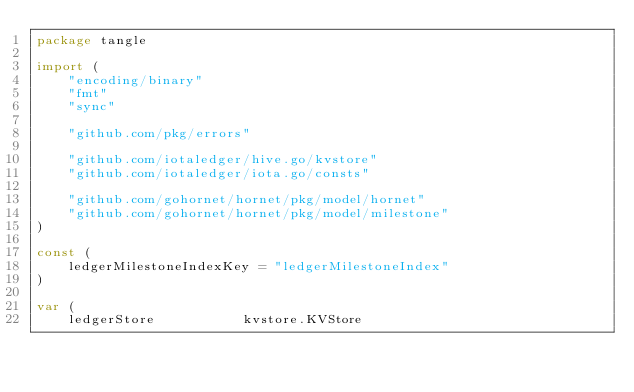<code> <loc_0><loc_0><loc_500><loc_500><_Go_>package tangle

import (
	"encoding/binary"
	"fmt"
	"sync"

	"github.com/pkg/errors"

	"github.com/iotaledger/hive.go/kvstore"
	"github.com/iotaledger/iota.go/consts"

	"github.com/gohornet/hornet/pkg/model/hornet"
	"github.com/gohornet/hornet/pkg/model/milestone"
)

const (
	ledgerMilestoneIndexKey = "ledgerMilestoneIndex"
)

var (
	ledgerStore           kvstore.KVStore</code> 